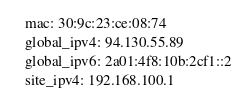<code> <loc_0><loc_0><loc_500><loc_500><_YAML_>  mac: 30:9c:23:ce:08:74
  global_ipv4: 94.130.55.89
  global_ipv6: 2a01:4f8:10b:2cf1::2
  site_ipv4: 192.168.100.1
</code> 